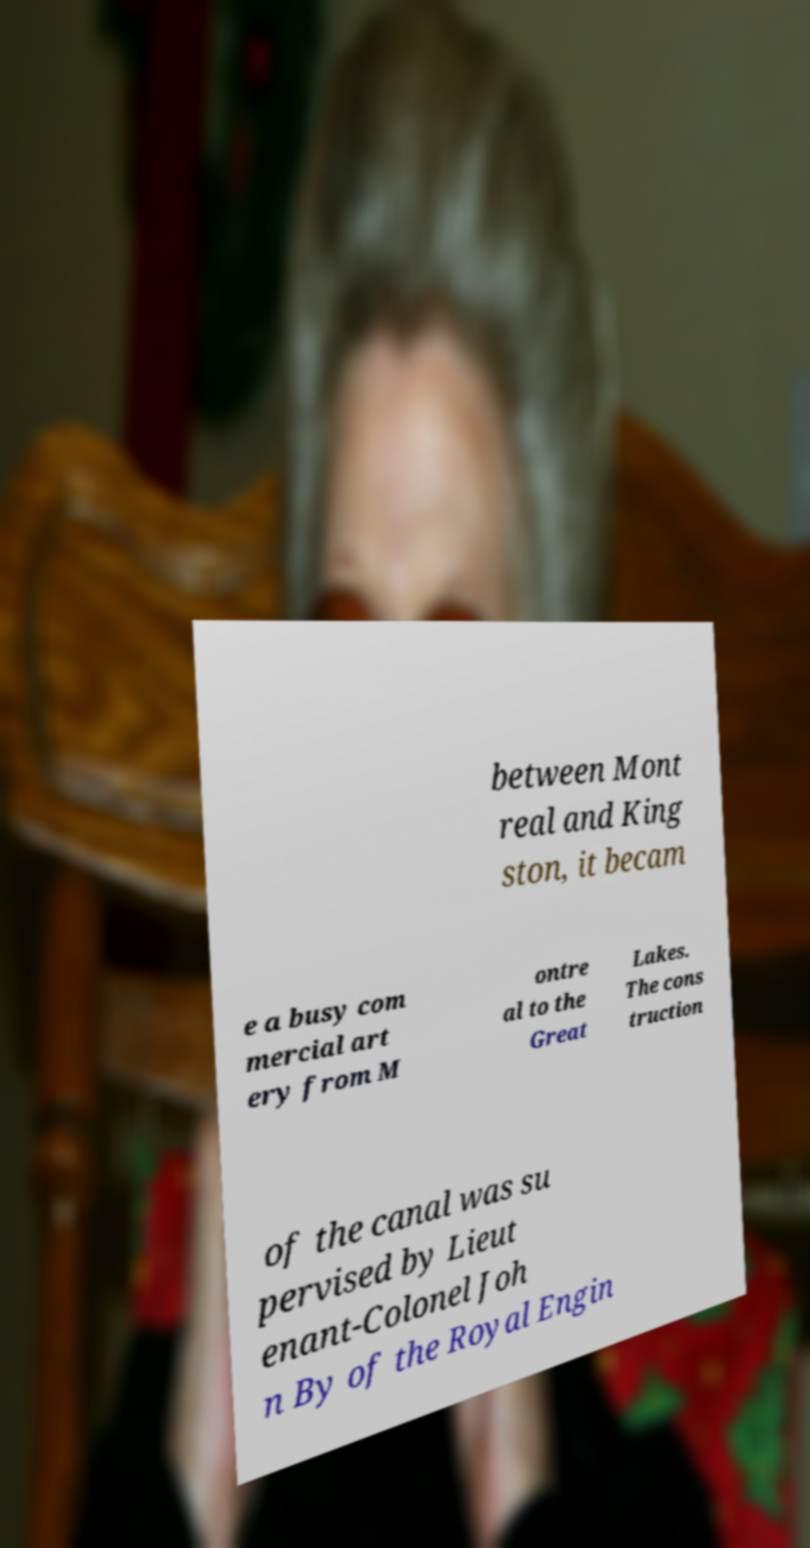I need the written content from this picture converted into text. Can you do that? between Mont real and King ston, it becam e a busy com mercial art ery from M ontre al to the Great Lakes. The cons truction of the canal was su pervised by Lieut enant-Colonel Joh n By of the Royal Engin 